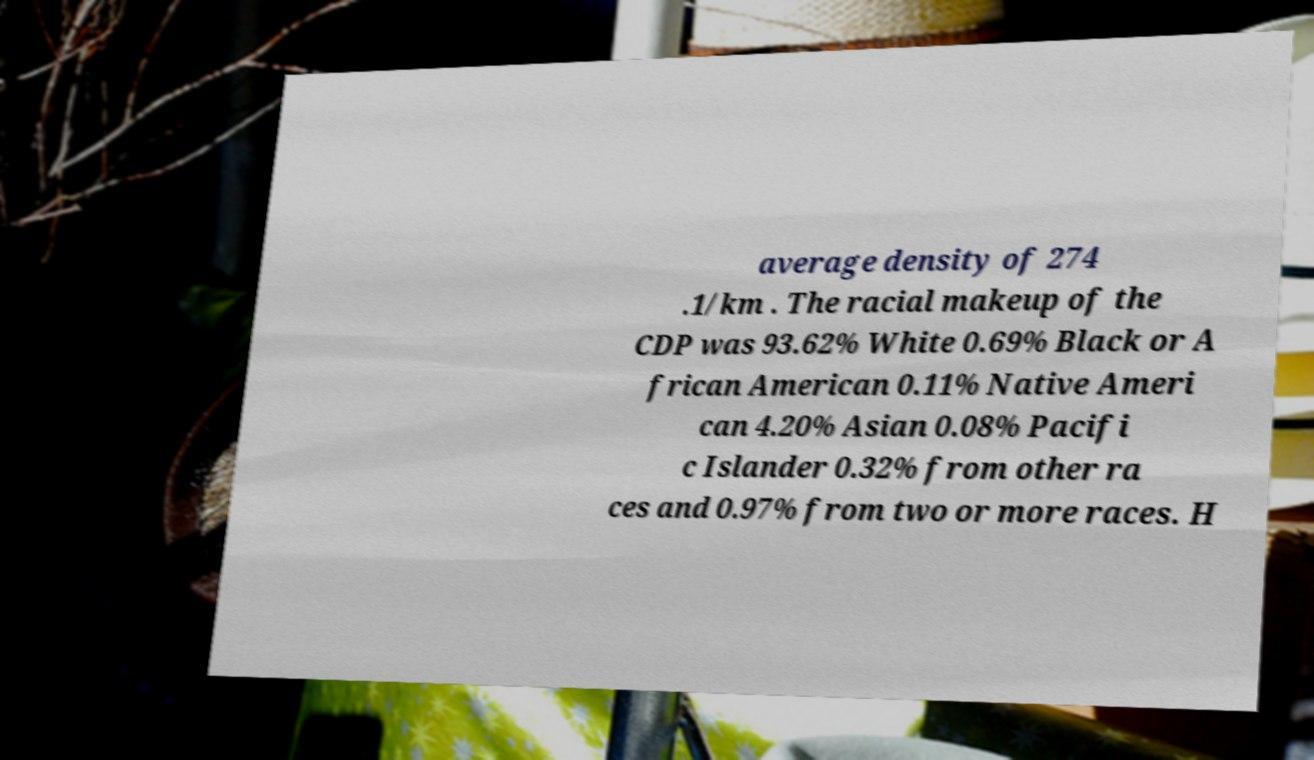Can you accurately transcribe the text from the provided image for me? average density of 274 .1/km . The racial makeup of the CDP was 93.62% White 0.69% Black or A frican American 0.11% Native Ameri can 4.20% Asian 0.08% Pacifi c Islander 0.32% from other ra ces and 0.97% from two or more races. H 